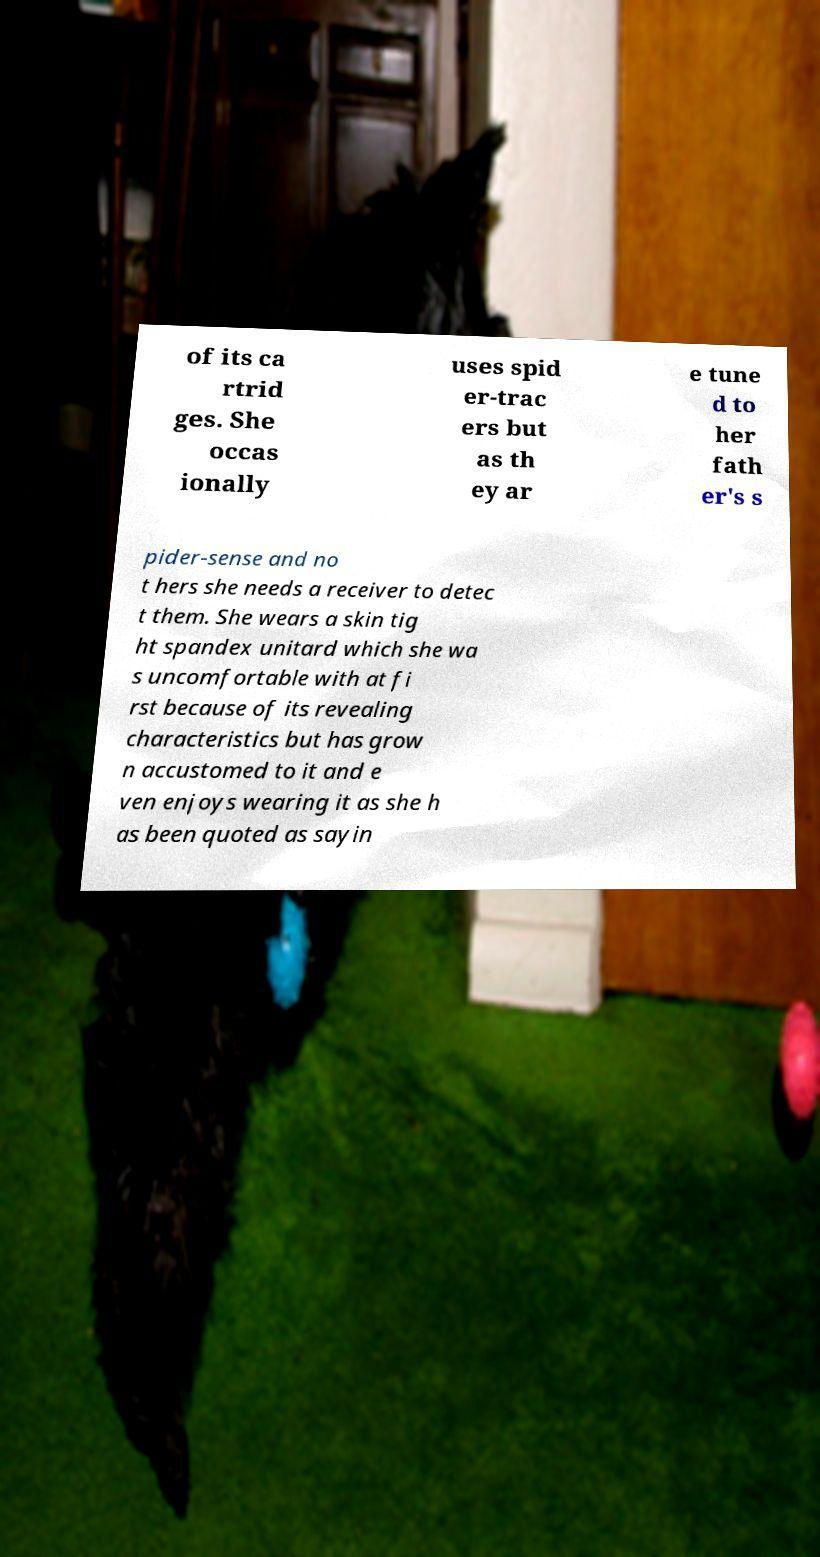I need the written content from this picture converted into text. Can you do that? of its ca rtrid ges. She occas ionally uses spid er-trac ers but as th ey ar e tune d to her fath er's s pider-sense and no t hers she needs a receiver to detec t them. She wears a skin tig ht spandex unitard which she wa s uncomfortable with at fi rst because of its revealing characteristics but has grow n accustomed to it and e ven enjoys wearing it as she h as been quoted as sayin 